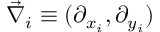Convert formula to latex. <formula><loc_0><loc_0><loc_500><loc_500>\vec { \nabla } _ { i } \equiv ( \partial _ { x _ { i } } , \partial _ { y _ { i } } )</formula> 